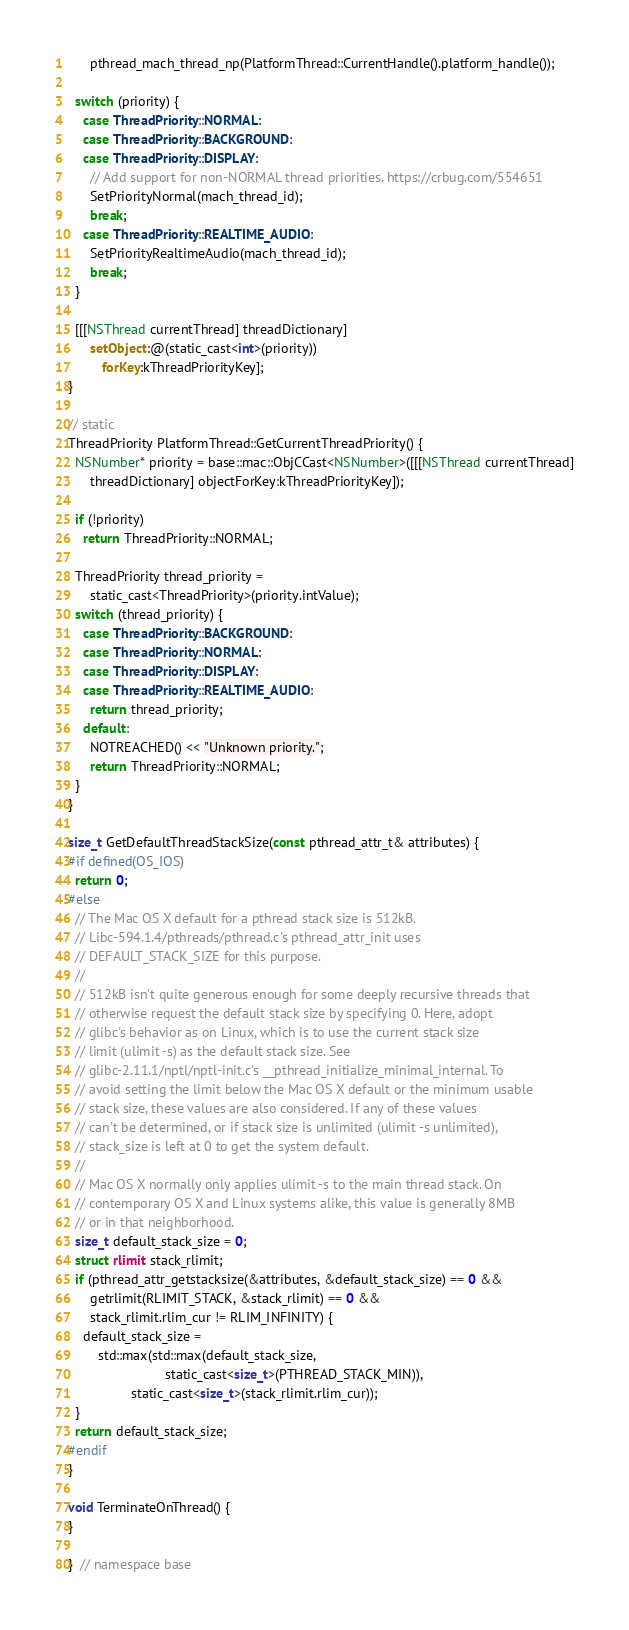Convert code to text. <code><loc_0><loc_0><loc_500><loc_500><_ObjectiveC_>      pthread_mach_thread_np(PlatformThread::CurrentHandle().platform_handle());

  switch (priority) {
    case ThreadPriority::NORMAL:
    case ThreadPriority::BACKGROUND:
    case ThreadPriority::DISPLAY:
      // Add support for non-NORMAL thread priorities. https://crbug.com/554651
      SetPriorityNormal(mach_thread_id);
      break;
    case ThreadPriority::REALTIME_AUDIO:
      SetPriorityRealtimeAudio(mach_thread_id);
      break;
  }

  [[[NSThread currentThread] threadDictionary]
      setObject:@(static_cast<int>(priority))
         forKey:kThreadPriorityKey];
}

// static
ThreadPriority PlatformThread::GetCurrentThreadPriority() {
  NSNumber* priority = base::mac::ObjCCast<NSNumber>([[[NSThread currentThread]
      threadDictionary] objectForKey:kThreadPriorityKey]);

  if (!priority)
    return ThreadPriority::NORMAL;

  ThreadPriority thread_priority =
      static_cast<ThreadPriority>(priority.intValue);
  switch (thread_priority) {
    case ThreadPriority::BACKGROUND:
    case ThreadPriority::NORMAL:
    case ThreadPriority::DISPLAY:
    case ThreadPriority::REALTIME_AUDIO:
      return thread_priority;
    default:
      NOTREACHED() << "Unknown priority.";
      return ThreadPriority::NORMAL;
  }
}

size_t GetDefaultThreadStackSize(const pthread_attr_t& attributes) {
#if defined(OS_IOS)
  return 0;
#else
  // The Mac OS X default for a pthread stack size is 512kB.
  // Libc-594.1.4/pthreads/pthread.c's pthread_attr_init uses
  // DEFAULT_STACK_SIZE for this purpose.
  //
  // 512kB isn't quite generous enough for some deeply recursive threads that
  // otherwise request the default stack size by specifying 0. Here, adopt
  // glibc's behavior as on Linux, which is to use the current stack size
  // limit (ulimit -s) as the default stack size. See
  // glibc-2.11.1/nptl/nptl-init.c's __pthread_initialize_minimal_internal. To
  // avoid setting the limit below the Mac OS X default or the minimum usable
  // stack size, these values are also considered. If any of these values
  // can't be determined, or if stack size is unlimited (ulimit -s unlimited),
  // stack_size is left at 0 to get the system default.
  //
  // Mac OS X normally only applies ulimit -s to the main thread stack. On
  // contemporary OS X and Linux systems alike, this value is generally 8MB
  // or in that neighborhood.
  size_t default_stack_size = 0;
  struct rlimit stack_rlimit;
  if (pthread_attr_getstacksize(&attributes, &default_stack_size) == 0 &&
      getrlimit(RLIMIT_STACK, &stack_rlimit) == 0 &&
      stack_rlimit.rlim_cur != RLIM_INFINITY) {
    default_stack_size =
        std::max(std::max(default_stack_size,
                          static_cast<size_t>(PTHREAD_STACK_MIN)),
                 static_cast<size_t>(stack_rlimit.rlim_cur));
  }
  return default_stack_size;
#endif
}

void TerminateOnThread() {
}

}  // namespace base
</code> 